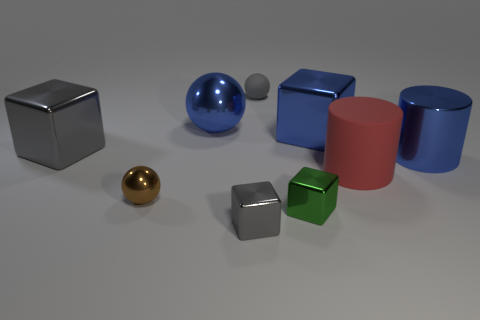What color is the rubber object that is the same size as the blue metal cylinder?
Your answer should be compact. Red. Are there any cylinders that have the same color as the large metallic ball?
Give a very brief answer. Yes. There is a blue object to the left of the small gray shiny cube; is its shape the same as the tiny gray object that is on the left side of the tiny gray sphere?
Give a very brief answer. No. What number of other objects are there of the same size as the green shiny thing?
Offer a terse response. 3. Do the matte sphere and the large block that is in front of the big blue shiny block have the same color?
Your response must be concise. Yes. Are there fewer shiny things that are on the right side of the tiny gray rubber thing than objects that are in front of the big gray block?
Your answer should be compact. Yes. What is the color of the thing that is both on the left side of the small gray rubber object and in front of the brown thing?
Your answer should be compact. Gray. Is the size of the green shiny object the same as the gray metallic object that is in front of the tiny brown sphere?
Your answer should be compact. Yes. The large blue thing that is to the right of the large rubber cylinder has what shape?
Make the answer very short. Cylinder. Are there more gray matte things behind the blue ball than big yellow shiny cylinders?
Your answer should be compact. Yes. 